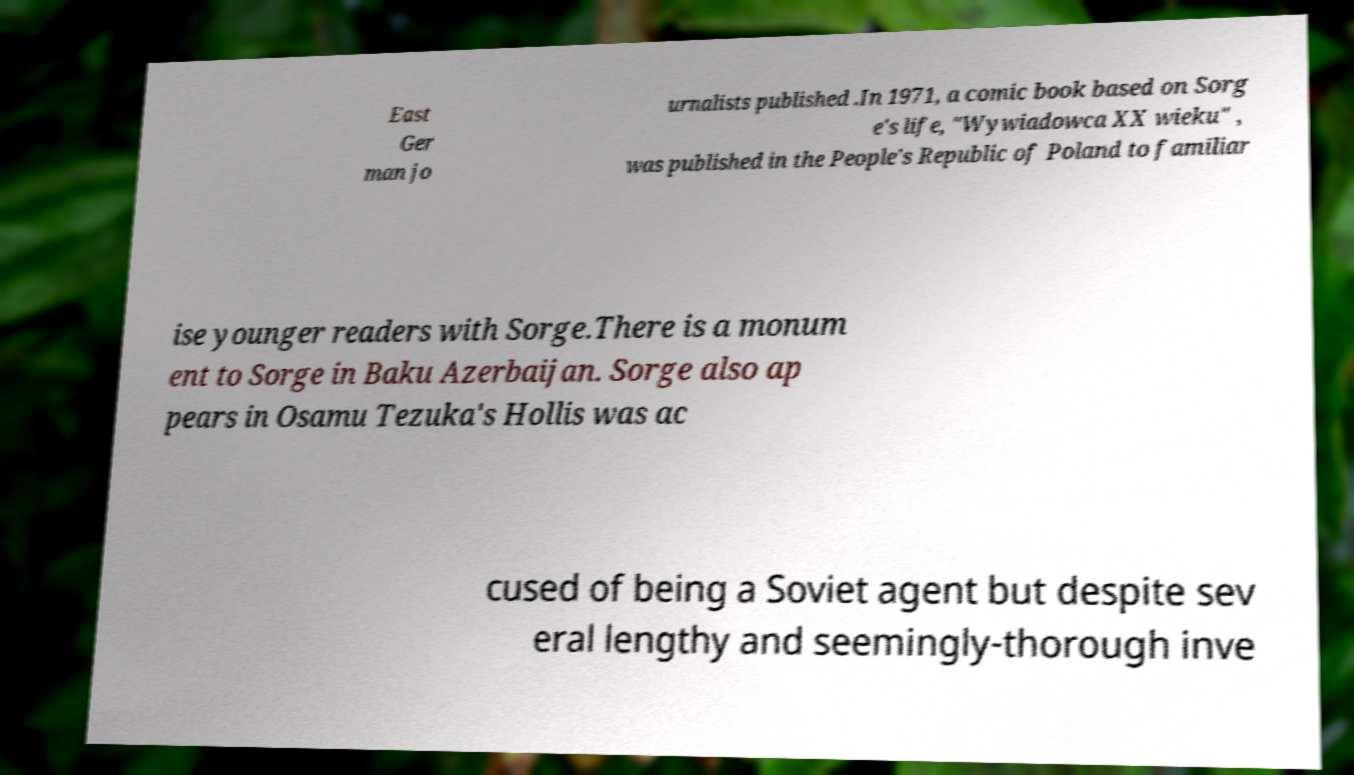Please read and relay the text visible in this image. What does it say? East Ger man jo urnalists published .In 1971, a comic book based on Sorg e's life, "Wywiadowca XX wieku" , was published in the People's Republic of Poland to familiar ise younger readers with Sorge.There is a monum ent to Sorge in Baku Azerbaijan. Sorge also ap pears in Osamu Tezuka's Hollis was ac cused of being a Soviet agent but despite sev eral lengthy and seemingly-thorough inve 